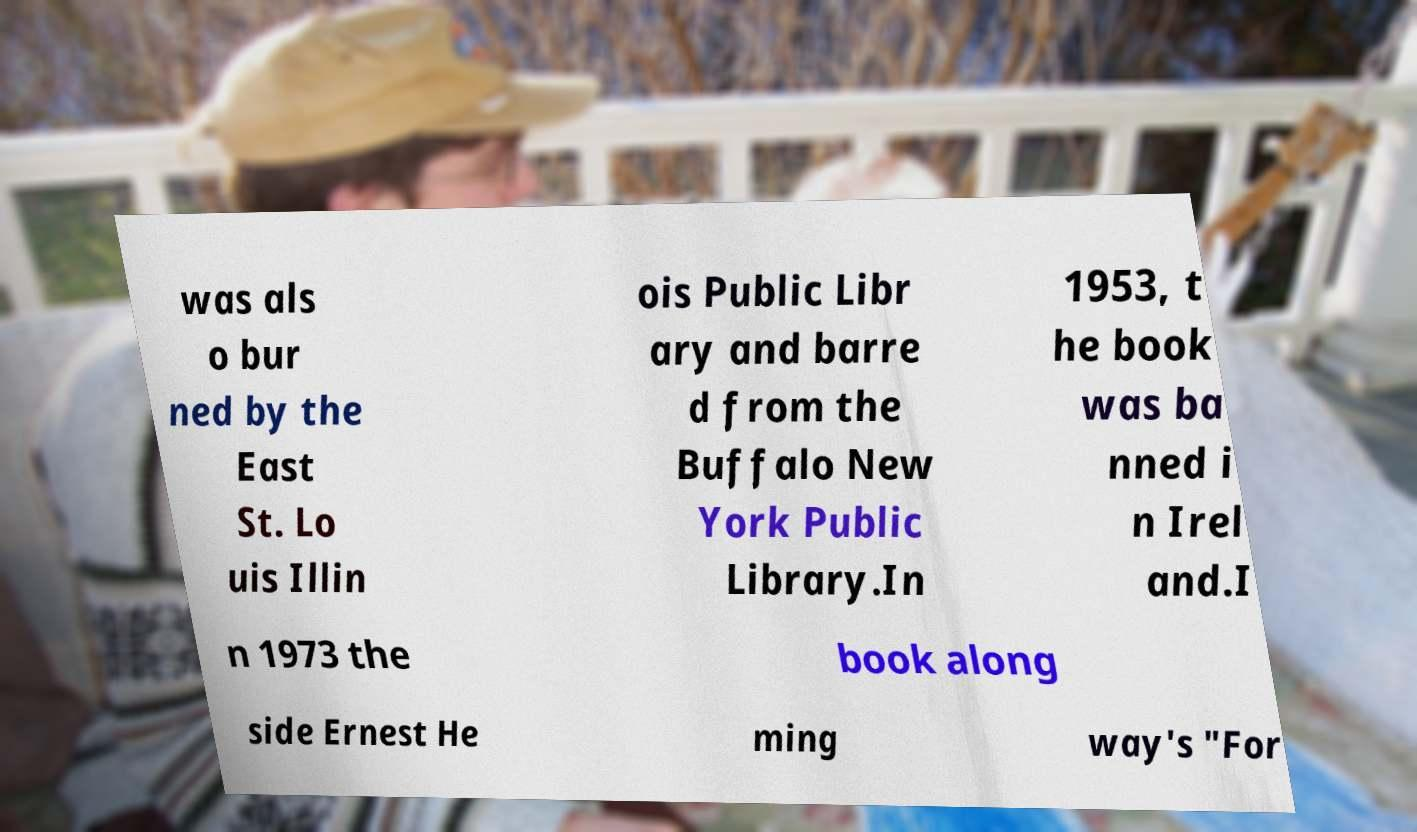Can you accurately transcribe the text from the provided image for me? was als o bur ned by the East St. Lo uis Illin ois Public Libr ary and barre d from the Buffalo New York Public Library.In 1953, t he book was ba nned i n Irel and.I n 1973 the book along side Ernest He ming way's "For 